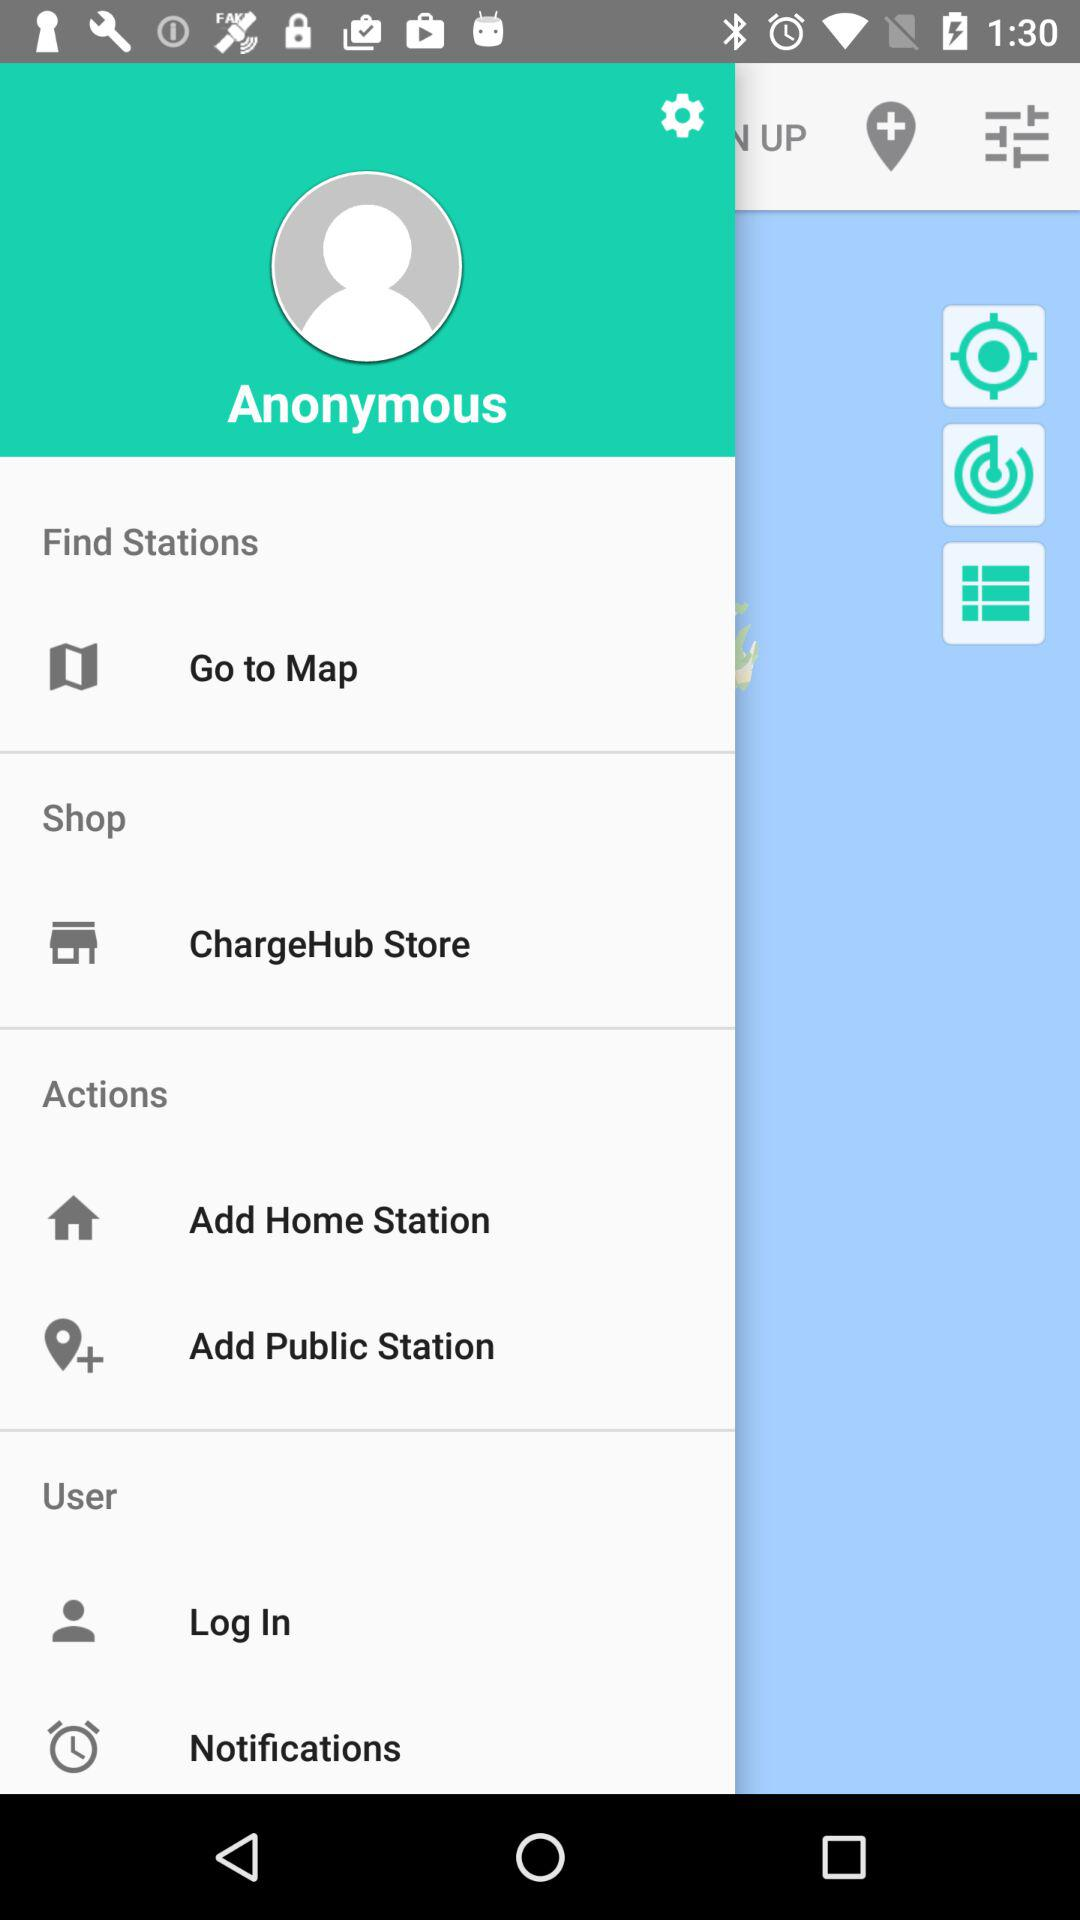Which public station has been added?
When the provided information is insufficient, respond with <no answer>. <no answer> 